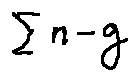Convert formula to latex. <formula><loc_0><loc_0><loc_500><loc_500>\sum n - g</formula> 